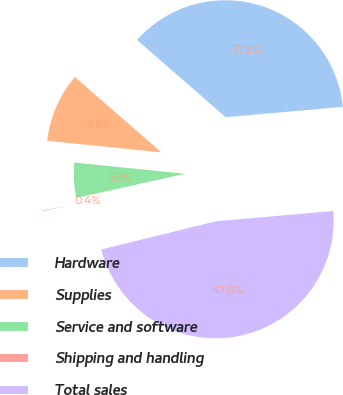Convert chart. <chart><loc_0><loc_0><loc_500><loc_500><pie_chart><fcel>Hardware<fcel>Supplies<fcel>Service and software<fcel>Shipping and handling<fcel>Total sales<nl><fcel>37.2%<fcel>9.8%<fcel>5.08%<fcel>0.36%<fcel>47.57%<nl></chart> 